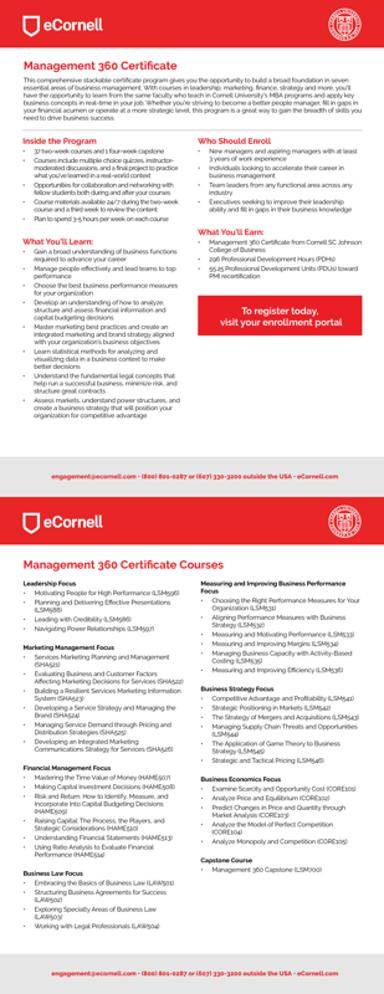What is the main topic of the text in the image? The main topic of the text in the image is the eCornell Management 360 Certificate, offering a comprehensive suite of courses designed to enhance managerial skills across various business functions. 